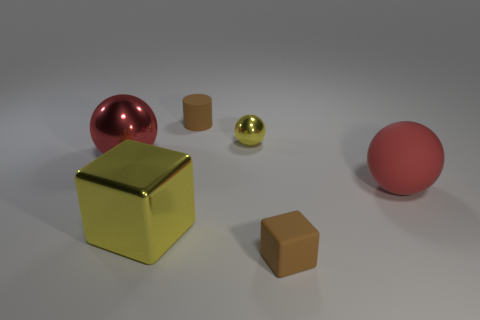Subtract all matte balls. How many balls are left? 2 Add 1 tiny brown matte blocks. How many objects exist? 7 Subtract all yellow blocks. How many blocks are left? 1 Subtract all red blocks. How many red balls are left? 2 Subtract all cylinders. How many objects are left? 5 Subtract 1 balls. How many balls are left? 2 Subtract all tiny cubes. Subtract all large metallic objects. How many objects are left? 3 Add 6 brown matte cylinders. How many brown matte cylinders are left? 7 Add 6 yellow spheres. How many yellow spheres exist? 7 Subtract 1 yellow spheres. How many objects are left? 5 